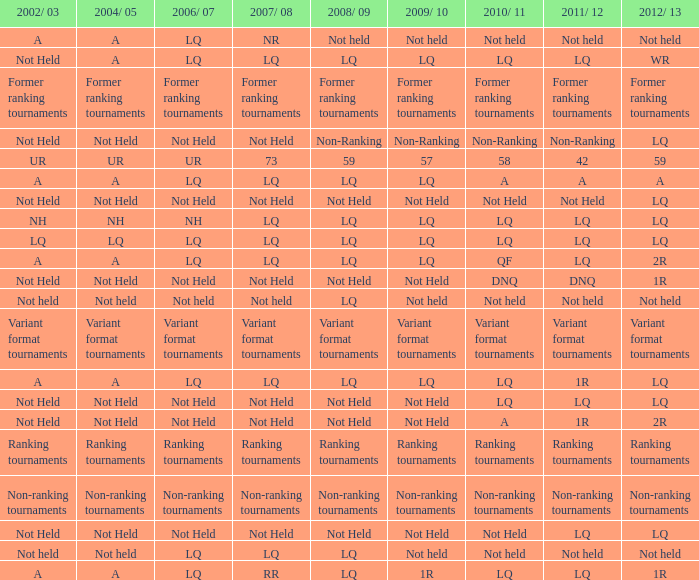Name the 2006/07 with 2011/12 of lq and 2010/11 of lq with 2002/03 of lq LQ. 